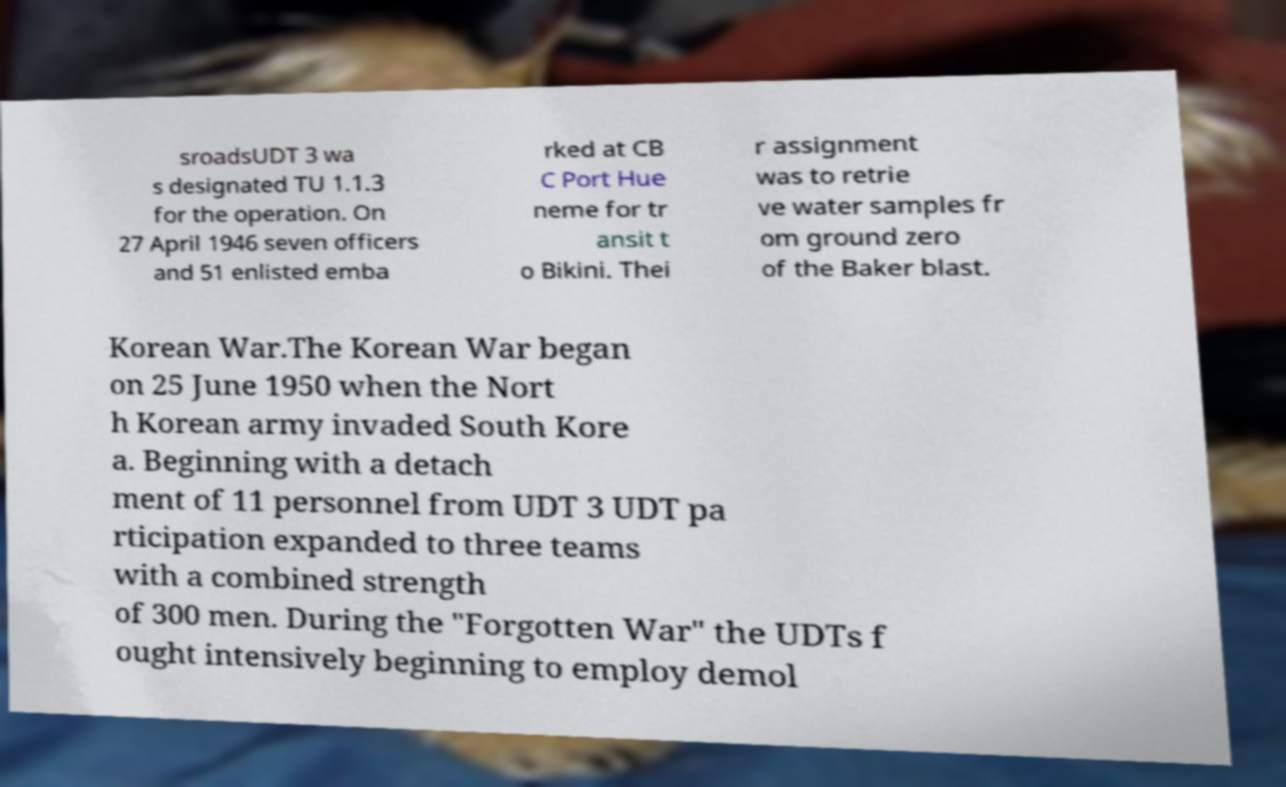Can you read and provide the text displayed in the image?This photo seems to have some interesting text. Can you extract and type it out for me? sroadsUDT 3 wa s designated TU 1.1.3 for the operation. On 27 April 1946 seven officers and 51 enlisted emba rked at CB C Port Hue neme for tr ansit t o Bikini. Thei r assignment was to retrie ve water samples fr om ground zero of the Baker blast. Korean War.The Korean War began on 25 June 1950 when the Nort h Korean army invaded South Kore a. Beginning with a detach ment of 11 personnel from UDT 3 UDT pa rticipation expanded to three teams with a combined strength of 300 men. During the "Forgotten War" the UDTs f ought intensively beginning to employ demol 